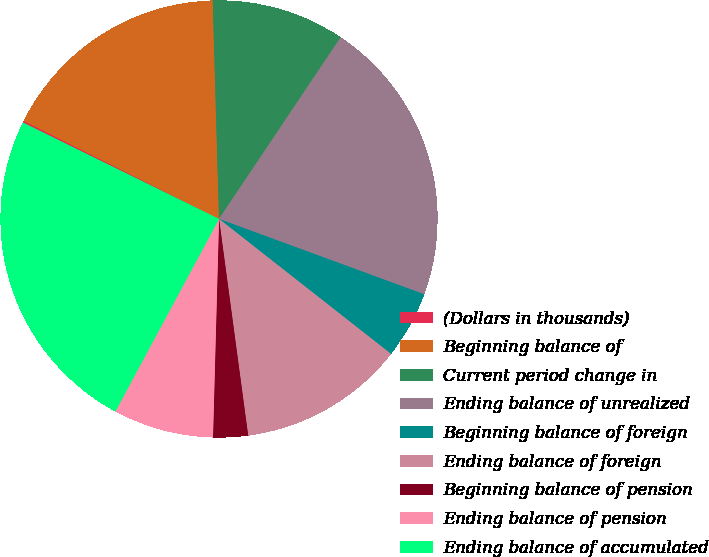<chart> <loc_0><loc_0><loc_500><loc_500><pie_chart><fcel>(Dollars in thousands)<fcel>Beginning balance of<fcel>Current period change in<fcel>Ending balance of unrealized<fcel>Beginning balance of foreign<fcel>Ending balance of foreign<fcel>Beginning balance of pension<fcel>Ending balance of pension<fcel>Ending balance of accumulated<nl><fcel>0.14%<fcel>17.13%<fcel>9.85%<fcel>21.21%<fcel>4.99%<fcel>12.28%<fcel>2.57%<fcel>7.42%<fcel>24.41%<nl></chart> 